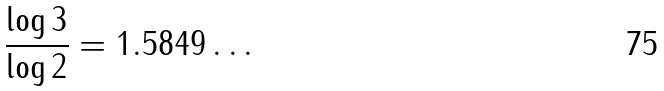<formula> <loc_0><loc_0><loc_500><loc_500>\frac { \log 3 } { \log 2 } = 1 . 5 8 4 9 \dots</formula> 